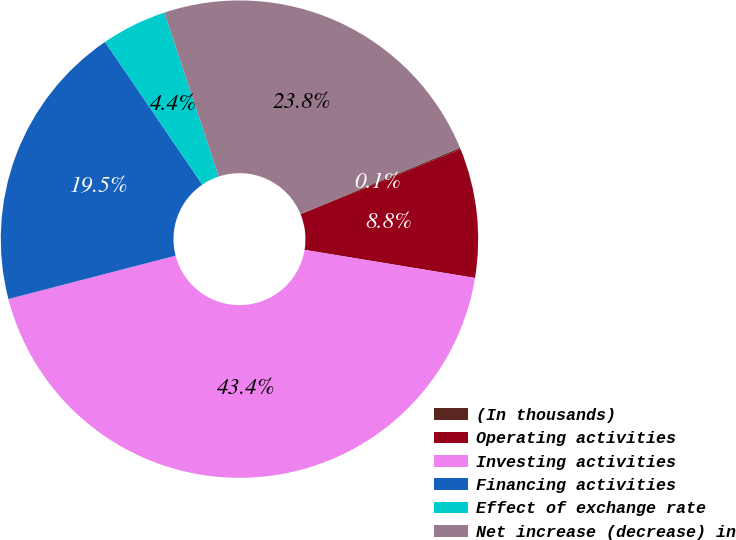Convert chart. <chart><loc_0><loc_0><loc_500><loc_500><pie_chart><fcel>(In thousands)<fcel>Operating activities<fcel>Investing activities<fcel>Financing activities<fcel>Effect of exchange rate<fcel>Net increase (decrease) in<nl><fcel>0.1%<fcel>8.75%<fcel>43.36%<fcel>19.51%<fcel>4.43%<fcel>23.84%<nl></chart> 